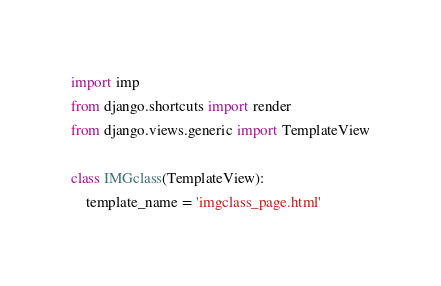Convert code to text. <code><loc_0><loc_0><loc_500><loc_500><_Python_>import imp
from django.shortcuts import render
from django.views.generic import TemplateView

class IMGclass(TemplateView):
    template_name = 'imgclass_page.html'</code> 